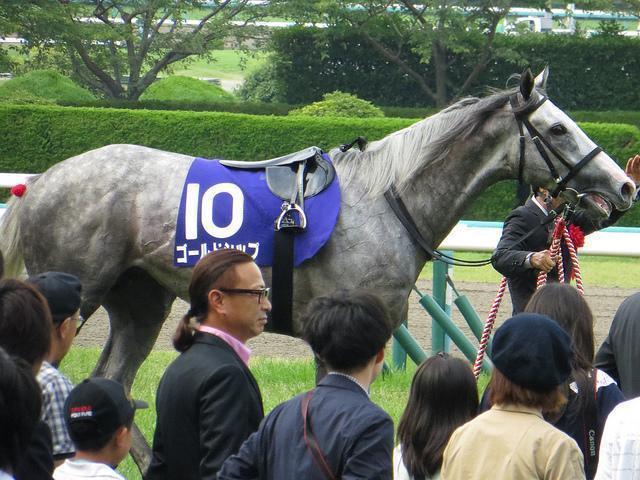What does the number ten indicate?
Pick the correct solution from the four options below to address the question.
Options: Starting position, betting odds, his age, his ranking. Starting position. 